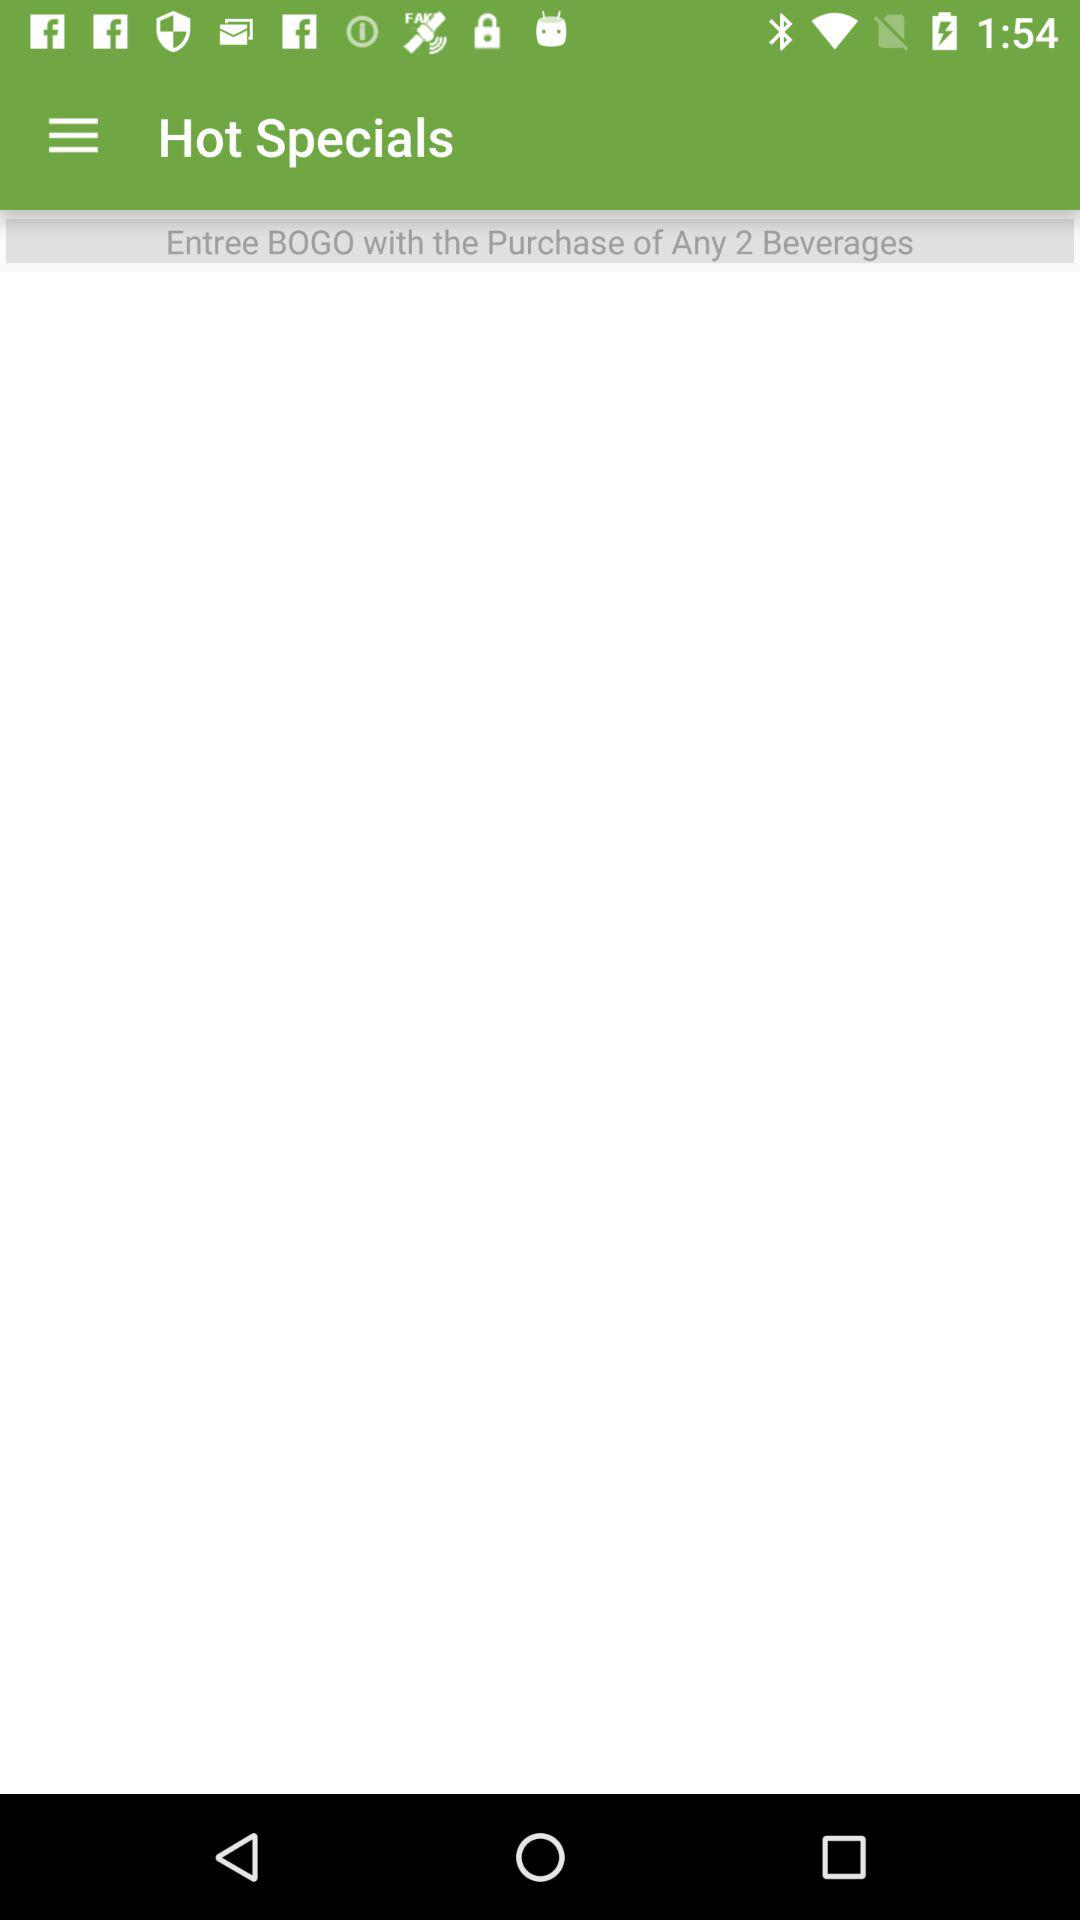How many beverages are required to get an entree BOGO?
Answer the question using a single word or phrase. 2 